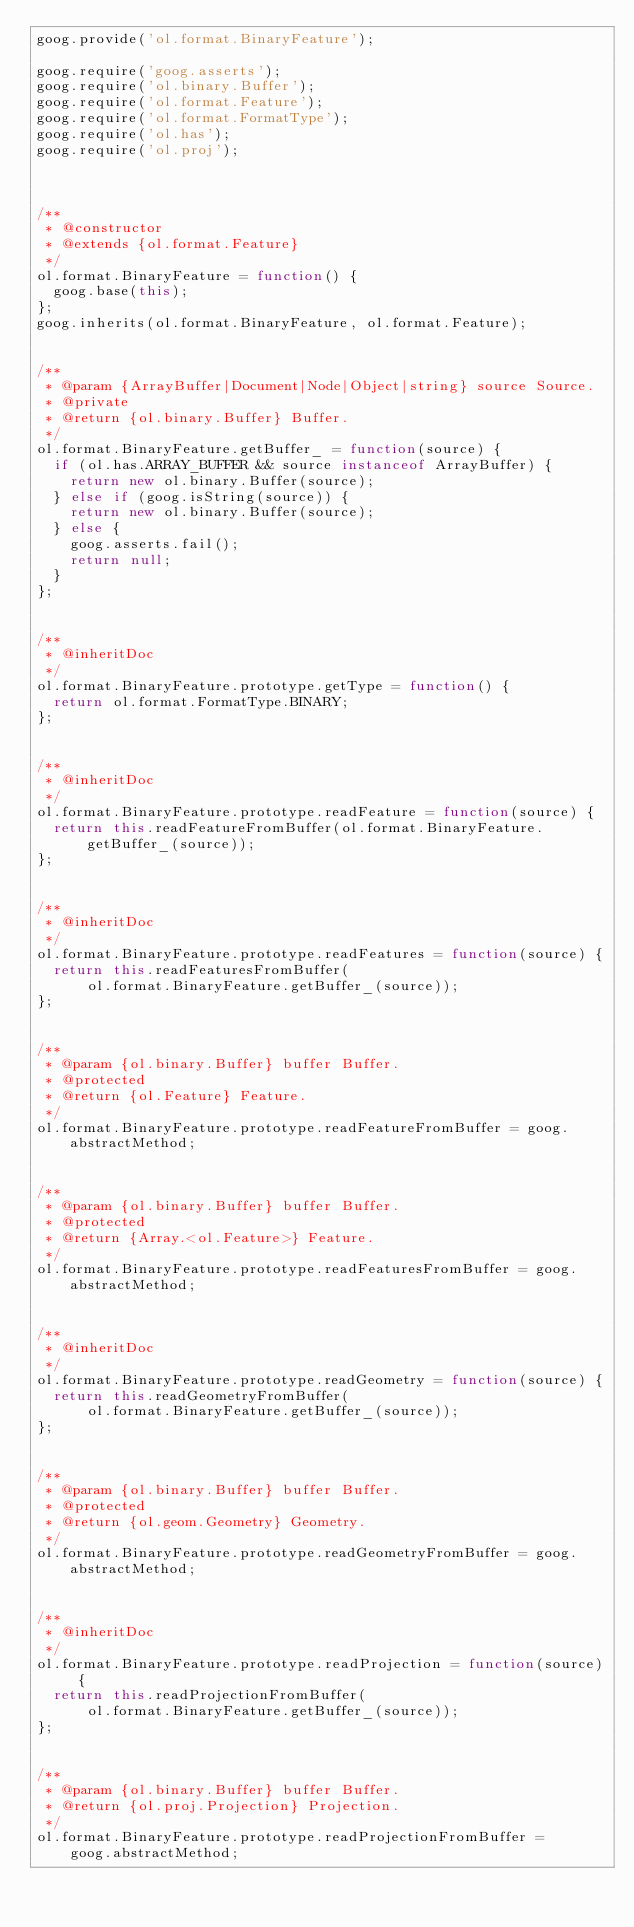<code> <loc_0><loc_0><loc_500><loc_500><_JavaScript_>goog.provide('ol.format.BinaryFeature');

goog.require('goog.asserts');
goog.require('ol.binary.Buffer');
goog.require('ol.format.Feature');
goog.require('ol.format.FormatType');
goog.require('ol.has');
goog.require('ol.proj');



/**
 * @constructor
 * @extends {ol.format.Feature}
 */
ol.format.BinaryFeature = function() {
  goog.base(this);
};
goog.inherits(ol.format.BinaryFeature, ol.format.Feature);


/**
 * @param {ArrayBuffer|Document|Node|Object|string} source Source.
 * @private
 * @return {ol.binary.Buffer} Buffer.
 */
ol.format.BinaryFeature.getBuffer_ = function(source) {
  if (ol.has.ARRAY_BUFFER && source instanceof ArrayBuffer) {
    return new ol.binary.Buffer(source);
  } else if (goog.isString(source)) {
    return new ol.binary.Buffer(source);
  } else {
    goog.asserts.fail();
    return null;
  }
};


/**
 * @inheritDoc
 */
ol.format.BinaryFeature.prototype.getType = function() {
  return ol.format.FormatType.BINARY;
};


/**
 * @inheritDoc
 */
ol.format.BinaryFeature.prototype.readFeature = function(source) {
  return this.readFeatureFromBuffer(ol.format.BinaryFeature.getBuffer_(source));
};


/**
 * @inheritDoc
 */
ol.format.BinaryFeature.prototype.readFeatures = function(source) {
  return this.readFeaturesFromBuffer(
      ol.format.BinaryFeature.getBuffer_(source));
};


/**
 * @param {ol.binary.Buffer} buffer Buffer.
 * @protected
 * @return {ol.Feature} Feature.
 */
ol.format.BinaryFeature.prototype.readFeatureFromBuffer = goog.abstractMethod;


/**
 * @param {ol.binary.Buffer} buffer Buffer.
 * @protected
 * @return {Array.<ol.Feature>} Feature.
 */
ol.format.BinaryFeature.prototype.readFeaturesFromBuffer = goog.abstractMethod;


/**
 * @inheritDoc
 */
ol.format.BinaryFeature.prototype.readGeometry = function(source) {
  return this.readGeometryFromBuffer(
      ol.format.BinaryFeature.getBuffer_(source));
};


/**
 * @param {ol.binary.Buffer} buffer Buffer.
 * @protected
 * @return {ol.geom.Geometry} Geometry.
 */
ol.format.BinaryFeature.prototype.readGeometryFromBuffer = goog.abstractMethod;


/**
 * @inheritDoc
 */
ol.format.BinaryFeature.prototype.readProjection = function(source) {
  return this.readProjectionFromBuffer(
      ol.format.BinaryFeature.getBuffer_(source));
};


/**
 * @param {ol.binary.Buffer} buffer Buffer.
 * @return {ol.proj.Projection} Projection.
 */
ol.format.BinaryFeature.prototype.readProjectionFromBuffer =
    goog.abstractMethod;
</code> 